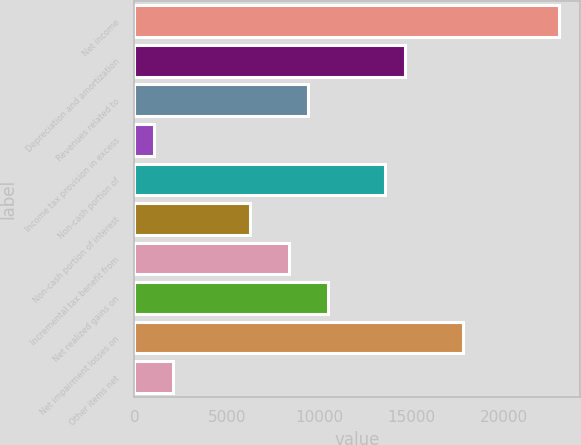Convert chart. <chart><loc_0><loc_0><loc_500><loc_500><bar_chart><fcel>Net income<fcel>Depreciation and amortization<fcel>Revenues related to<fcel>Income tax provision in excess<fcel>Non-cash portion of<fcel>Non-cash portion of interest<fcel>Incremental tax benefit from<fcel>Net realized gains on<fcel>Net impairment losses on<fcel>Other items net<nl><fcel>22968.6<fcel>14618.2<fcel>9399.2<fcel>1048.8<fcel>13574.4<fcel>6267.8<fcel>8355.4<fcel>10443<fcel>17749.6<fcel>2092.6<nl></chart> 